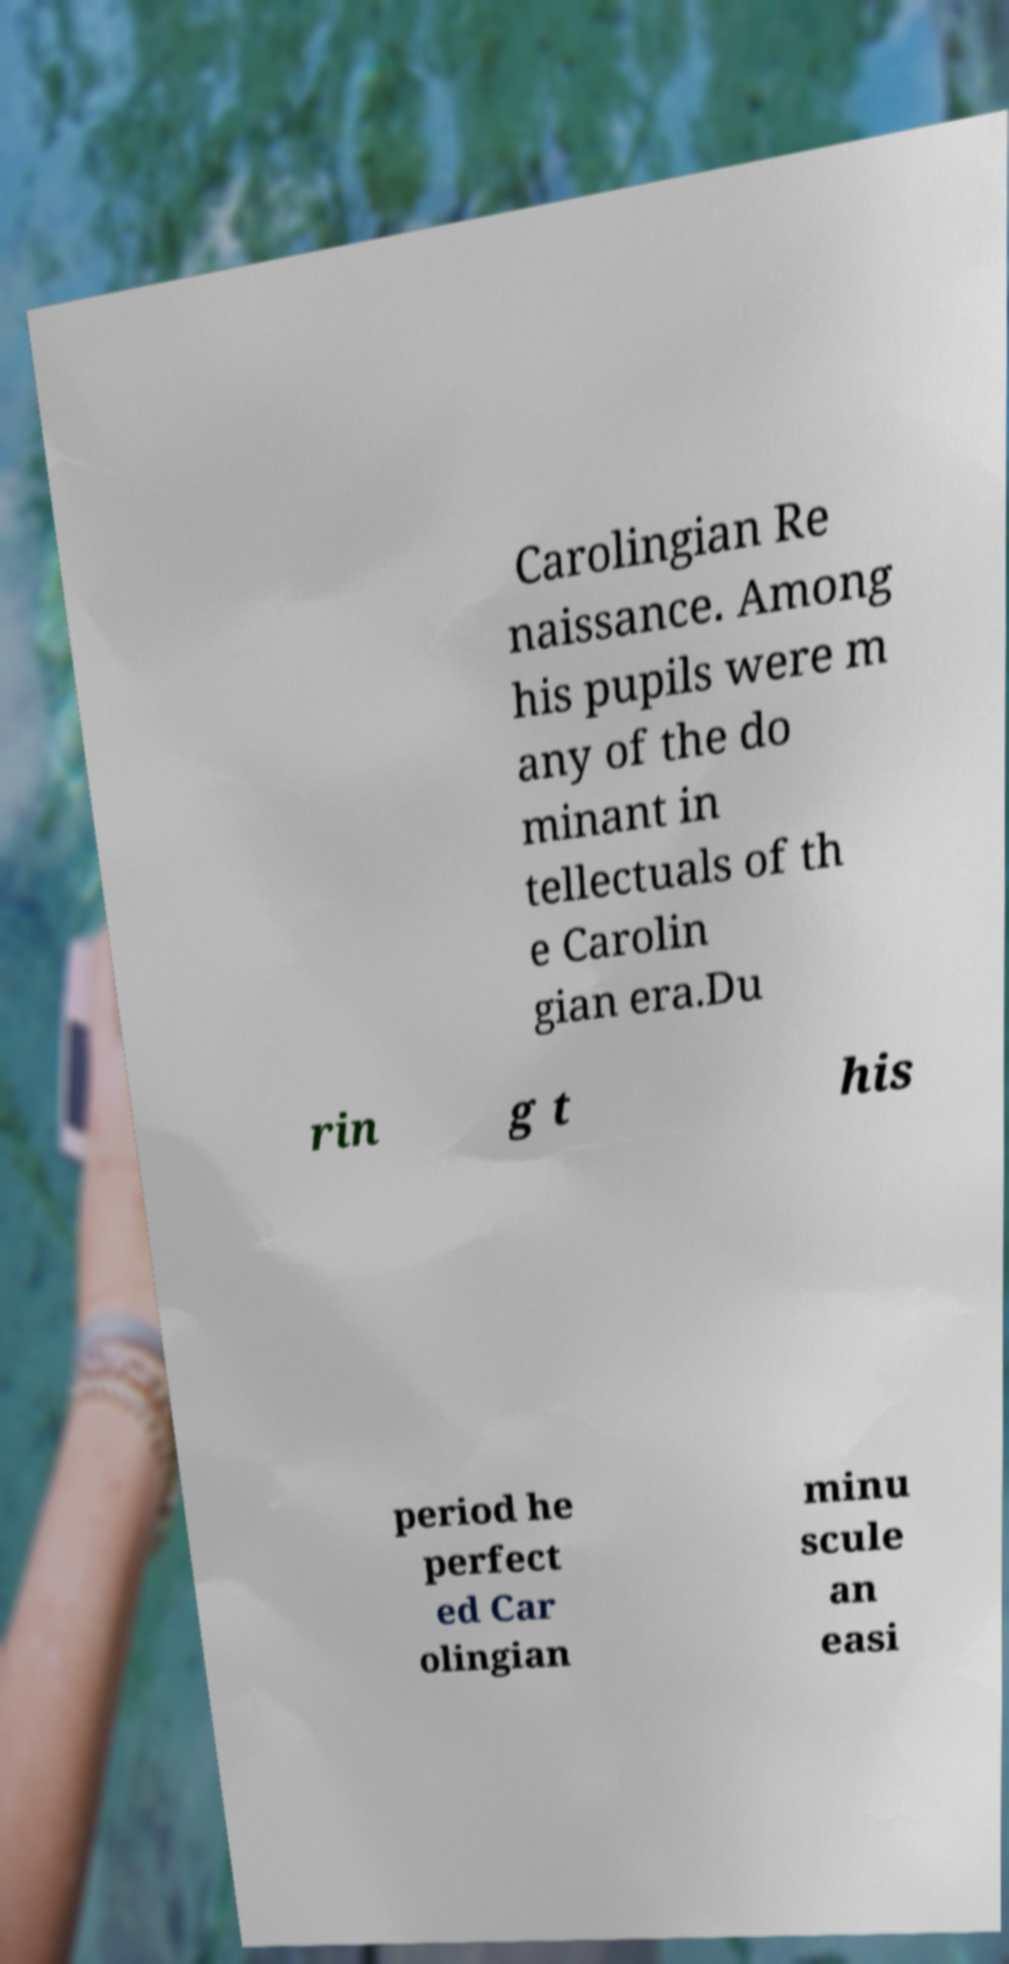I need the written content from this picture converted into text. Can you do that? Carolingian Re naissance. Among his pupils were m any of the do minant in tellectuals of th e Carolin gian era.Du rin g t his period he perfect ed Car olingian minu scule an easi 